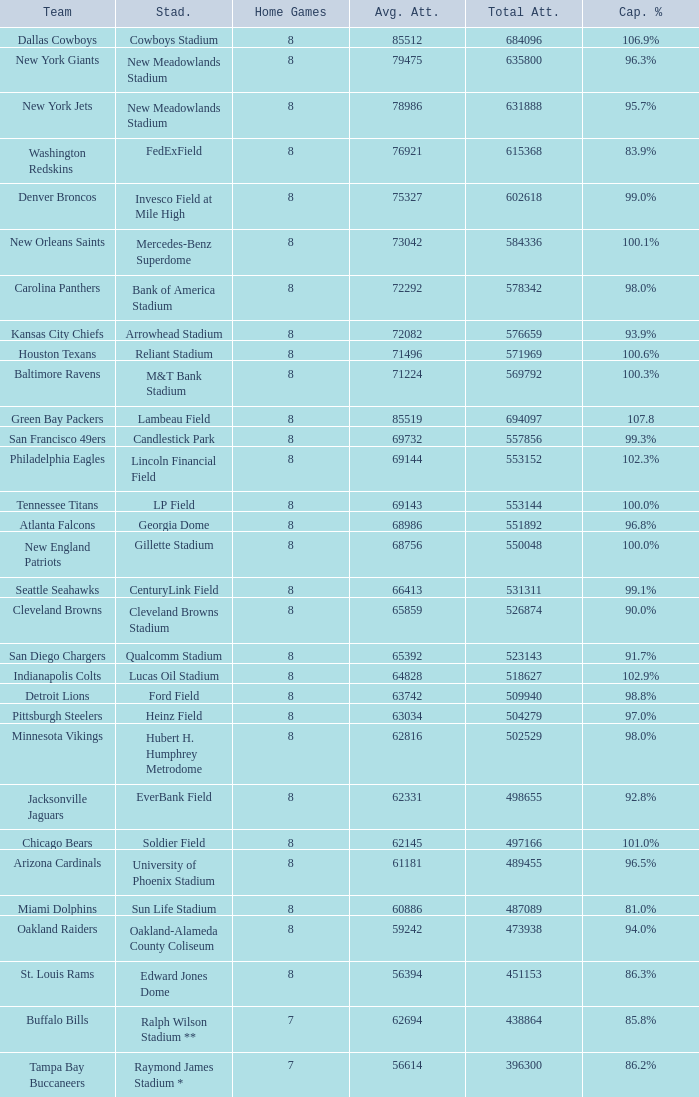Parse the full table. {'header': ['Team', 'Stad.', 'Home Games', 'Avg. Att.', 'Total Att.', 'Cap. %'], 'rows': [['Dallas Cowboys', 'Cowboys Stadium', '8', '85512', '684096', '106.9%'], ['New York Giants', 'New Meadowlands Stadium', '8', '79475', '635800', '96.3%'], ['New York Jets', 'New Meadowlands Stadium', '8', '78986', '631888', '95.7%'], ['Washington Redskins', 'FedExField', '8', '76921', '615368', '83.9%'], ['Denver Broncos', 'Invesco Field at Mile High', '8', '75327', '602618', '99.0%'], ['New Orleans Saints', 'Mercedes-Benz Superdome', '8', '73042', '584336', '100.1%'], ['Carolina Panthers', 'Bank of America Stadium', '8', '72292', '578342', '98.0%'], ['Kansas City Chiefs', 'Arrowhead Stadium', '8', '72082', '576659', '93.9%'], ['Houston Texans', 'Reliant Stadium', '8', '71496', '571969', '100.6%'], ['Baltimore Ravens', 'M&T Bank Stadium', '8', '71224', '569792', '100.3%'], ['Green Bay Packers', 'Lambeau Field', '8', '85519', '694097', '107.8'], ['San Francisco 49ers', 'Candlestick Park', '8', '69732', '557856', '99.3%'], ['Philadelphia Eagles', 'Lincoln Financial Field', '8', '69144', '553152', '102.3%'], ['Tennessee Titans', 'LP Field', '8', '69143', '553144', '100.0%'], ['Atlanta Falcons', 'Georgia Dome', '8', '68986', '551892', '96.8%'], ['New England Patriots', 'Gillette Stadium', '8', '68756', '550048', '100.0%'], ['Seattle Seahawks', 'CenturyLink Field', '8', '66413', '531311', '99.1%'], ['Cleveland Browns', 'Cleveland Browns Stadium', '8', '65859', '526874', '90.0%'], ['San Diego Chargers', 'Qualcomm Stadium', '8', '65392', '523143', '91.7%'], ['Indianapolis Colts', 'Lucas Oil Stadium', '8', '64828', '518627', '102.9%'], ['Detroit Lions', 'Ford Field', '8', '63742', '509940', '98.8%'], ['Pittsburgh Steelers', 'Heinz Field', '8', '63034', '504279', '97.0%'], ['Minnesota Vikings', 'Hubert H. Humphrey Metrodome', '8', '62816', '502529', '98.0%'], ['Jacksonville Jaguars', 'EverBank Field', '8', '62331', '498655', '92.8%'], ['Chicago Bears', 'Soldier Field', '8', '62145', '497166', '101.0%'], ['Arizona Cardinals', 'University of Phoenix Stadium', '8', '61181', '489455', '96.5%'], ['Miami Dolphins', 'Sun Life Stadium', '8', '60886', '487089', '81.0%'], ['Oakland Raiders', 'Oakland-Alameda County Coliseum', '8', '59242', '473938', '94.0%'], ['St. Louis Rams', 'Edward Jones Dome', '8', '56394', '451153', '86.3%'], ['Buffalo Bills', 'Ralph Wilson Stadium **', '7', '62694', '438864', '85.8%'], ['Tampa Bay Buccaneers', 'Raymond James Stadium *', '7', '56614', '396300', '86.2%']]} How many average attendance has a capacity percentage of 96.5% 1.0. 